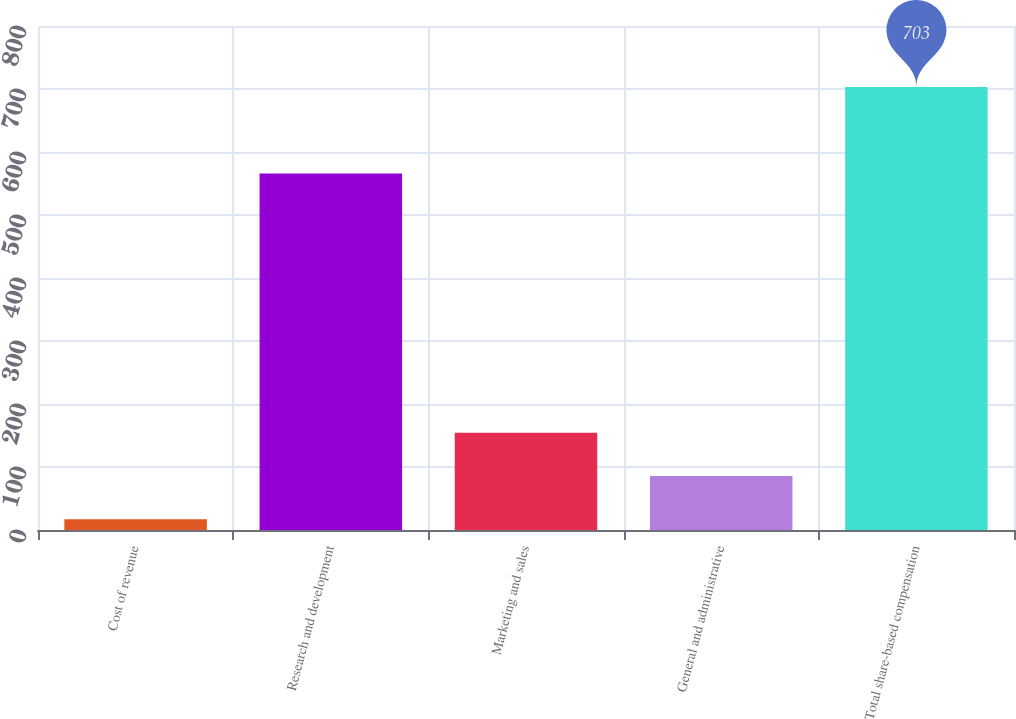<chart> <loc_0><loc_0><loc_500><loc_500><bar_chart><fcel>Cost of revenue<fcel>Research and development<fcel>Marketing and sales<fcel>General and administrative<fcel>Total share-based compensation<nl><fcel>17<fcel>566<fcel>154.2<fcel>85.6<fcel>703<nl></chart> 